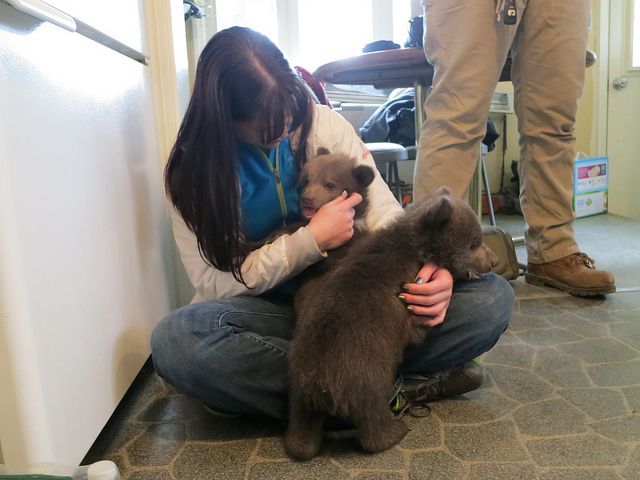<image>What is the relation between these cubs? I don't know the exact relation between these cubs, but they could possibly be siblings. What is the relation between these cubs? It is not clear what the relation between these cubs is. They can be siblings or part of the same family. 